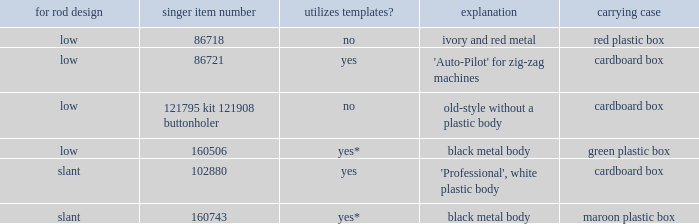What's the shank type of the buttonholer with red plastic box as storage case? Low. Write the full table. {'header': ['for rod design', 'singer item number', 'utilizes templates?', 'explanation', 'carrying case'], 'rows': [['low', '86718', 'no', 'ivory and red metal', 'red plastic box'], ['low', '86721', 'yes', "'Auto-Pilot' for zig-zag machines", 'cardboard box'], ['low', '121795 kit 121908 buttonholer', 'no', 'old-style without a plastic body', 'cardboard box'], ['low', '160506', 'yes*', 'black metal body', 'green plastic box'], ['slant', '102880', 'yes', "'Professional', white plastic body", 'cardboard box'], ['slant', '160743', 'yes*', 'black metal body', 'maroon plastic box']]} 